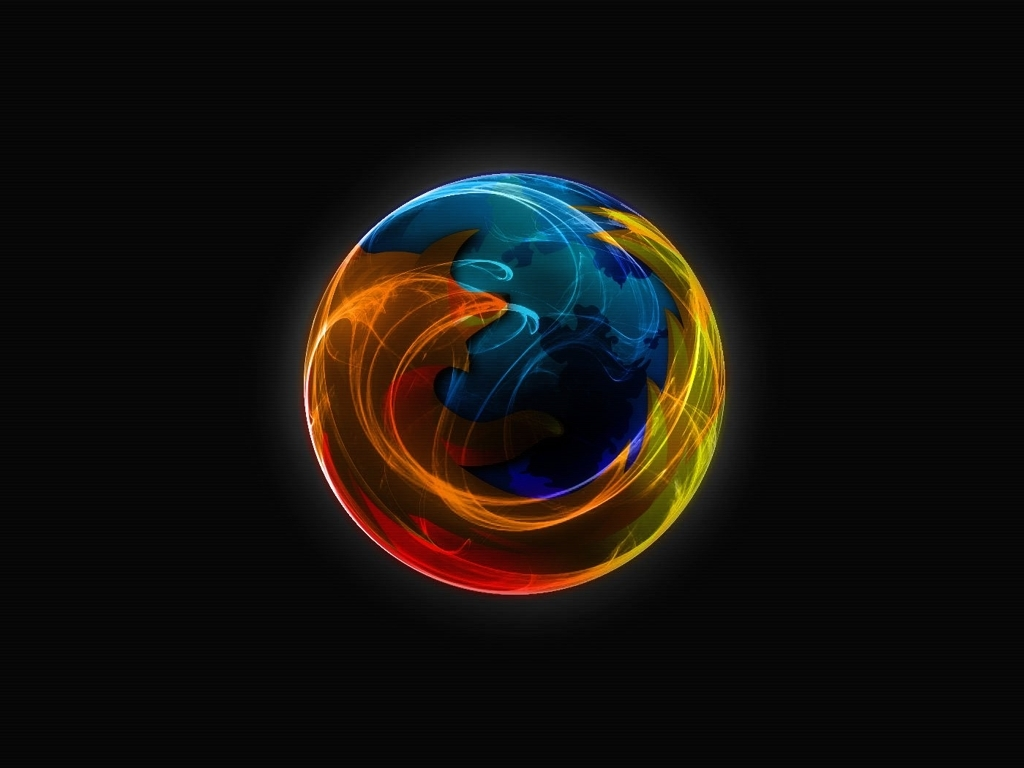What artistic techniques were used to create this image? The image appears to utilize digital art techniques, blending vibrant colors and using visual effects to create a sense of movement and depth, resembling a fiery and energetic version of a planet. 